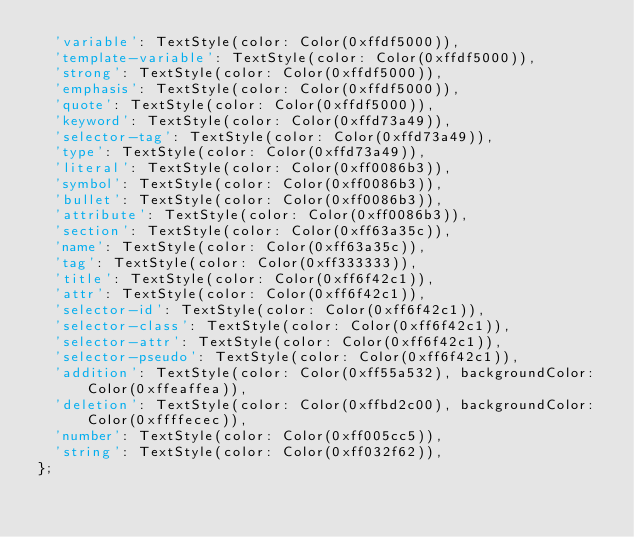Convert code to text. <code><loc_0><loc_0><loc_500><loc_500><_Dart_>  'variable': TextStyle(color: Color(0xffdf5000)),
  'template-variable': TextStyle(color: Color(0xffdf5000)),
  'strong': TextStyle(color: Color(0xffdf5000)),
  'emphasis': TextStyle(color: Color(0xffdf5000)),
  'quote': TextStyle(color: Color(0xffdf5000)),
  'keyword': TextStyle(color: Color(0xffd73a49)),
  'selector-tag': TextStyle(color: Color(0xffd73a49)),
  'type': TextStyle(color: Color(0xffd73a49)),
  'literal': TextStyle(color: Color(0xff0086b3)),
  'symbol': TextStyle(color: Color(0xff0086b3)),
  'bullet': TextStyle(color: Color(0xff0086b3)),
  'attribute': TextStyle(color: Color(0xff0086b3)),
  'section': TextStyle(color: Color(0xff63a35c)),
  'name': TextStyle(color: Color(0xff63a35c)),
  'tag': TextStyle(color: Color(0xff333333)),
  'title': TextStyle(color: Color(0xff6f42c1)),
  'attr': TextStyle(color: Color(0xff6f42c1)),
  'selector-id': TextStyle(color: Color(0xff6f42c1)),
  'selector-class': TextStyle(color: Color(0xff6f42c1)),
  'selector-attr': TextStyle(color: Color(0xff6f42c1)),
  'selector-pseudo': TextStyle(color: Color(0xff6f42c1)),
  'addition': TextStyle(color: Color(0xff55a532), backgroundColor: Color(0xffeaffea)),
  'deletion': TextStyle(color: Color(0xffbd2c00), backgroundColor: Color(0xffffecec)),
  'number': TextStyle(color: Color(0xff005cc5)),
  'string': TextStyle(color: Color(0xff032f62)),
};
</code> 